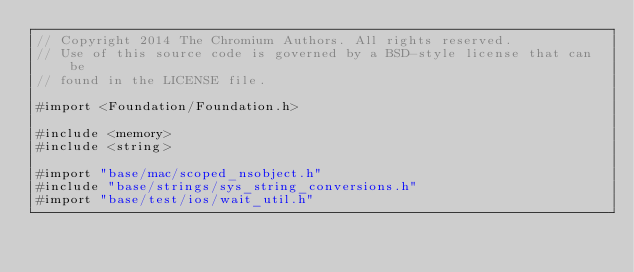<code> <loc_0><loc_0><loc_500><loc_500><_ObjectiveC_>// Copyright 2014 The Chromium Authors. All rights reserved.
// Use of this source code is governed by a BSD-style license that can be
// found in the LICENSE file.

#import <Foundation/Foundation.h>

#include <memory>
#include <string>

#import "base/mac/scoped_nsobject.h"
#include "base/strings/sys_string_conversions.h"
#import "base/test/ios/wait_util.h"</code> 